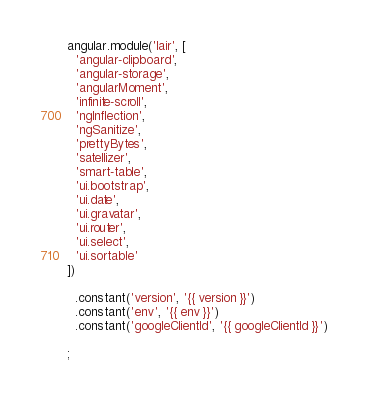<code> <loc_0><loc_0><loc_500><loc_500><_JavaScript_>angular.module('lair', [
  'angular-clipboard',
  'angular-storage',
  'angularMoment',
  'infinite-scroll',
  'ngInflection',
  'ngSanitize',
  'prettyBytes',
  'satellizer',
  'smart-table',
  'ui.bootstrap',
  'ui.date',
  'ui.gravatar',
  'ui.router',
  'ui.select',
  'ui.sortable'
])

  .constant('version', '{{ version }}')
  .constant('env', '{{ env }}')
  .constant('googleClientId', '{{ googleClientId }}')

;
</code> 